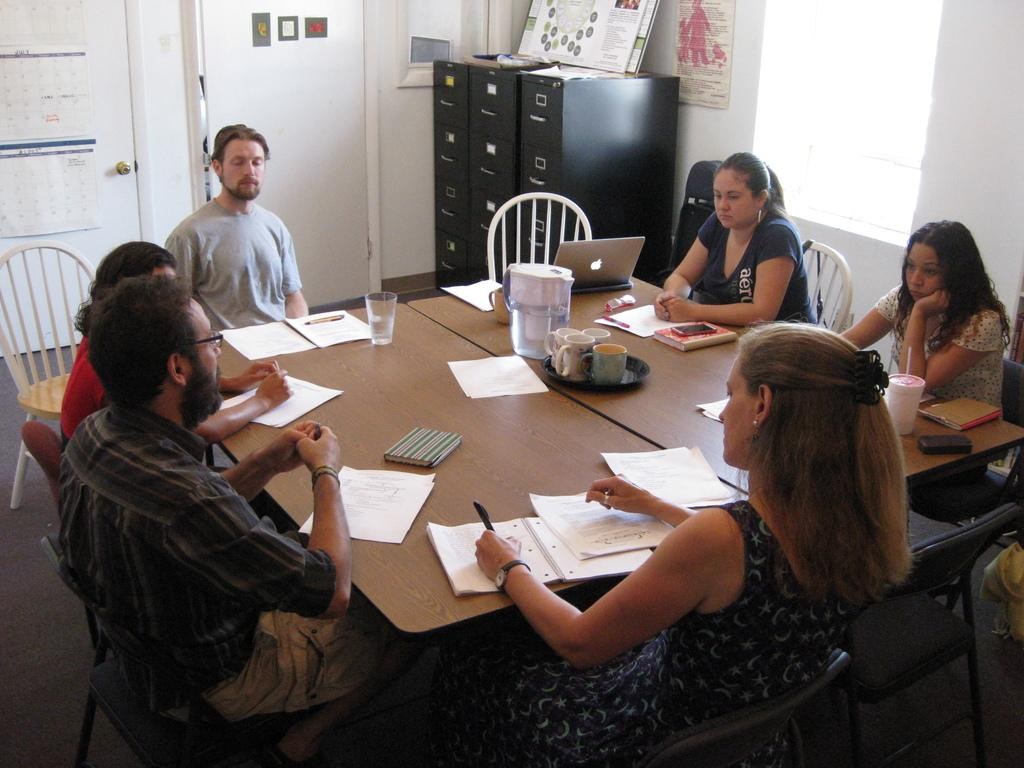What objects are on the table in the image? There are papers, a glass jar, and cups on the table in the image. What are the people holding in the image? The people are holding papers and pens. What is the purpose of the lockers in the room? The lockers are present in the room, but their purpose is not explicitly stated in the image. Can you describe the glass jar on the table? There is a glass jar in the middle of the table, but its contents or purpose are not specified in the image. How many forks are visible in the image? There are no forks visible in the image. What type of twist can be seen in the image? There is no twist present in the image. 